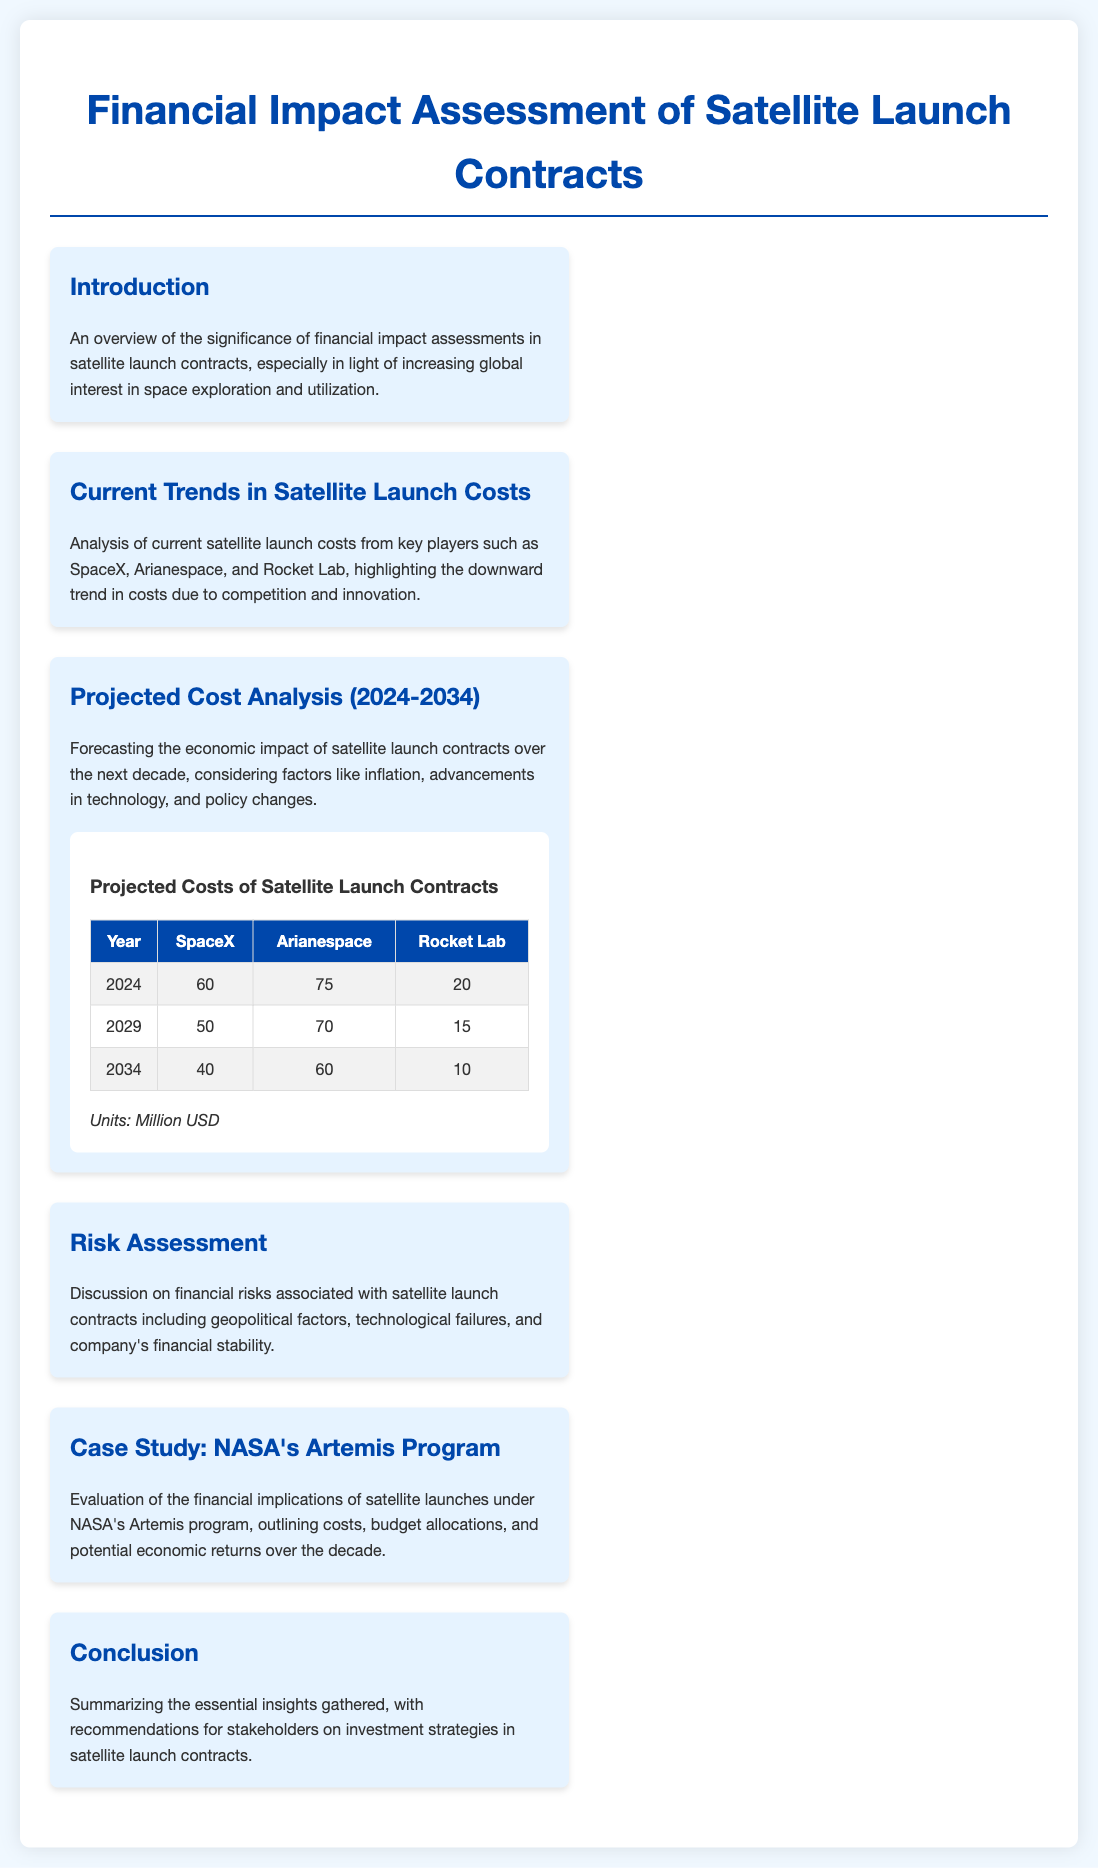what is the title of the document? The title is prominently displayed at the top of the document and indicates the focus on financial assessment regarding satellite launch contracts.
Answer: Financial Impact Assessment of Satellite Launch Contracts which company has the lowest projected cost in 2034? The projected costs table indicates the values for each company in 2034, showing which company has the lowest figure.
Answer: Rocket Lab what is the projected cost of SpaceX in 2029? The table lists specific projected costs for SpaceX in the year 2029.
Answer: 50 what are the key players analyzed in current satellite launch costs? The document mentions specific companies involved in satellite launches, highlighting competition in the industry.
Answer: SpaceX, Arianespace, Rocket Lab what is the focus of the risk assessment section? The risk assessment section outlines specific financial risks that need to be considered in the context of satellite launch contracts.
Answer: Financial risks how has the cost trend changed according to the document? The document discusses the general trend observed in satellite launch costs among the major players.
Answer: Downward trend what does the conclusion section provide? The conclusion wraps up insights acquired throughout the document and offers strategic guidance for stakeholders.
Answer: Recommendations for stakeholders what is one factor discussed affecting projected costs over the next decade? The document highlights several factors influencing the economic impact of satellite launch contracts in the future.
Answer: Inflation what type of analysis does the projected cost analysis section focus on? This section specifically focuses on forecasting the economic impact associated with satellite launch contracts.
Answer: Forecasting 